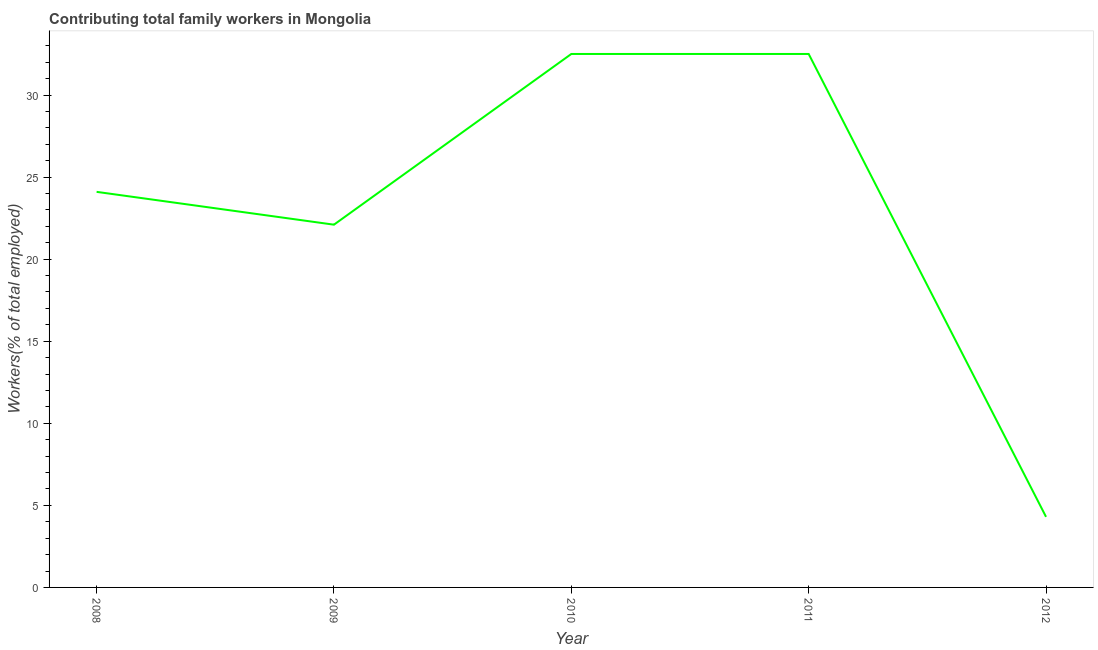What is the contributing family workers in 2011?
Your answer should be compact. 32.5. Across all years, what is the maximum contributing family workers?
Ensure brevity in your answer.  32.5. Across all years, what is the minimum contributing family workers?
Give a very brief answer. 4.3. In which year was the contributing family workers maximum?
Offer a terse response. 2010. What is the sum of the contributing family workers?
Ensure brevity in your answer.  115.5. What is the difference between the contributing family workers in 2008 and 2011?
Give a very brief answer. -8.4. What is the average contributing family workers per year?
Your answer should be compact. 23.1. What is the median contributing family workers?
Offer a terse response. 24.1. Do a majority of the years between 2009 and 2012 (inclusive) have contributing family workers greater than 13 %?
Offer a very short reply. Yes. What is the ratio of the contributing family workers in 2010 to that in 2012?
Keep it short and to the point. 7.56. Is the difference between the contributing family workers in 2009 and 2011 greater than the difference between any two years?
Offer a terse response. No. What is the difference between the highest and the lowest contributing family workers?
Make the answer very short. 28.2. In how many years, is the contributing family workers greater than the average contributing family workers taken over all years?
Give a very brief answer. 3. How many years are there in the graph?
Give a very brief answer. 5. What is the difference between two consecutive major ticks on the Y-axis?
Your answer should be compact. 5. Are the values on the major ticks of Y-axis written in scientific E-notation?
Give a very brief answer. No. What is the title of the graph?
Your answer should be compact. Contributing total family workers in Mongolia. What is the label or title of the Y-axis?
Make the answer very short. Workers(% of total employed). What is the Workers(% of total employed) in 2008?
Offer a terse response. 24.1. What is the Workers(% of total employed) of 2009?
Provide a short and direct response. 22.1. What is the Workers(% of total employed) of 2010?
Your answer should be compact. 32.5. What is the Workers(% of total employed) in 2011?
Your answer should be very brief. 32.5. What is the Workers(% of total employed) of 2012?
Make the answer very short. 4.3. What is the difference between the Workers(% of total employed) in 2008 and 2010?
Your answer should be very brief. -8.4. What is the difference between the Workers(% of total employed) in 2008 and 2012?
Offer a terse response. 19.8. What is the difference between the Workers(% of total employed) in 2009 and 2011?
Your response must be concise. -10.4. What is the difference between the Workers(% of total employed) in 2010 and 2011?
Your answer should be compact. 0. What is the difference between the Workers(% of total employed) in 2010 and 2012?
Your response must be concise. 28.2. What is the difference between the Workers(% of total employed) in 2011 and 2012?
Your answer should be compact. 28.2. What is the ratio of the Workers(% of total employed) in 2008 to that in 2009?
Provide a succinct answer. 1.09. What is the ratio of the Workers(% of total employed) in 2008 to that in 2010?
Your answer should be very brief. 0.74. What is the ratio of the Workers(% of total employed) in 2008 to that in 2011?
Make the answer very short. 0.74. What is the ratio of the Workers(% of total employed) in 2008 to that in 2012?
Offer a terse response. 5.61. What is the ratio of the Workers(% of total employed) in 2009 to that in 2010?
Give a very brief answer. 0.68. What is the ratio of the Workers(% of total employed) in 2009 to that in 2011?
Ensure brevity in your answer.  0.68. What is the ratio of the Workers(% of total employed) in 2009 to that in 2012?
Keep it short and to the point. 5.14. What is the ratio of the Workers(% of total employed) in 2010 to that in 2012?
Offer a terse response. 7.56. What is the ratio of the Workers(% of total employed) in 2011 to that in 2012?
Keep it short and to the point. 7.56. 